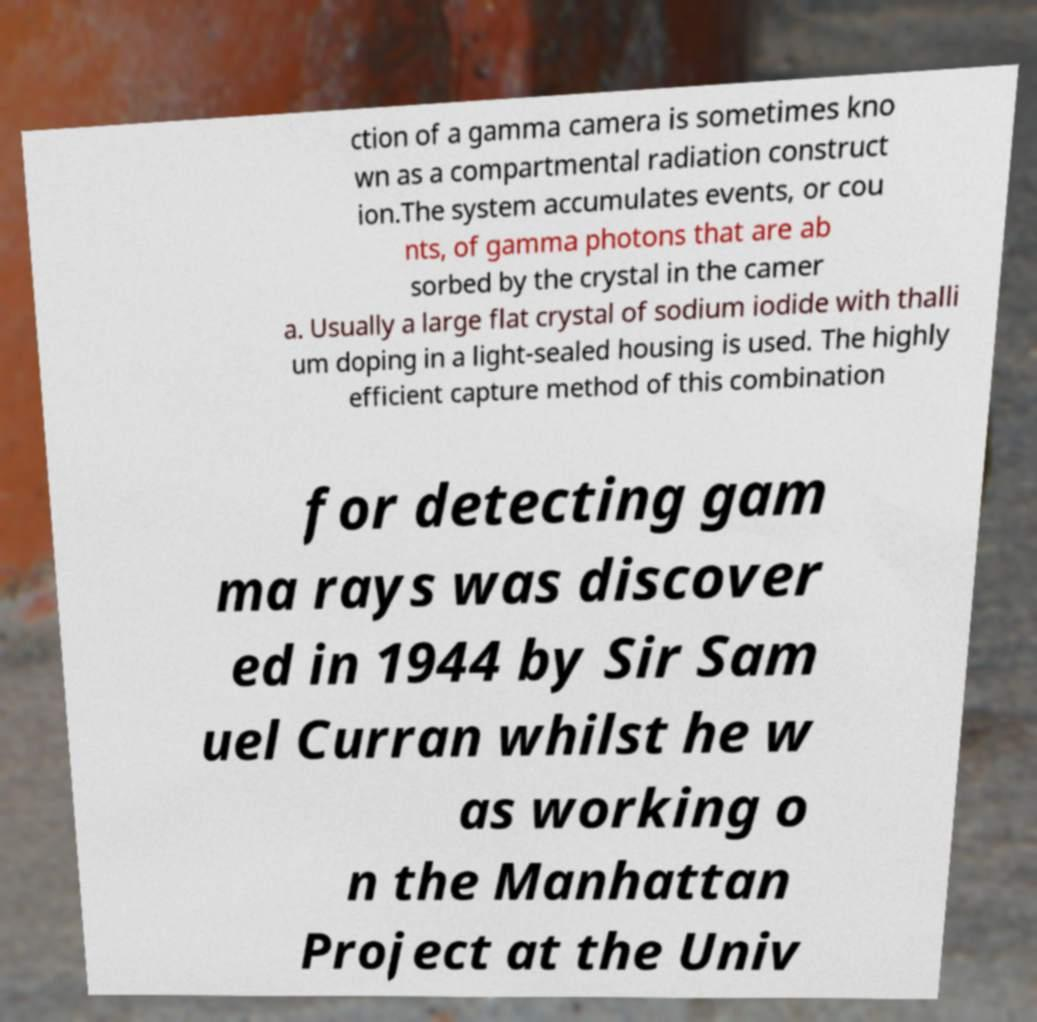Can you accurately transcribe the text from the provided image for me? ction of a gamma camera is sometimes kno wn as a compartmental radiation construct ion.The system accumulates events, or cou nts, of gamma photons that are ab sorbed by the crystal in the camer a. Usually a large flat crystal of sodium iodide with thalli um doping in a light-sealed housing is used. The highly efficient capture method of this combination for detecting gam ma rays was discover ed in 1944 by Sir Sam uel Curran whilst he w as working o n the Manhattan Project at the Univ 